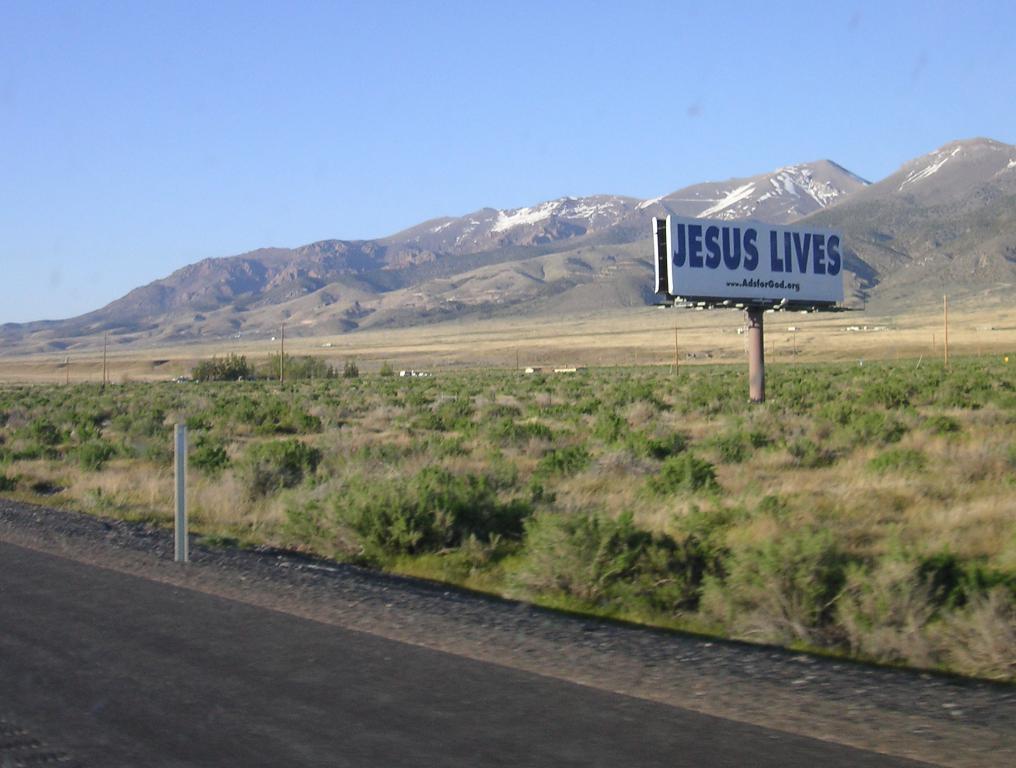What message is depicted in the sign by the side of the road?
Your answer should be compact. Jesus lives. Which website sponsored the sign?
Offer a terse response. Www.adsforgod.org. 